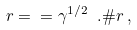<formula> <loc_0><loc_0><loc_500><loc_500>\ r = \ = \gamma ^ { 1 / 2 } \ . \# r \, ,</formula> 